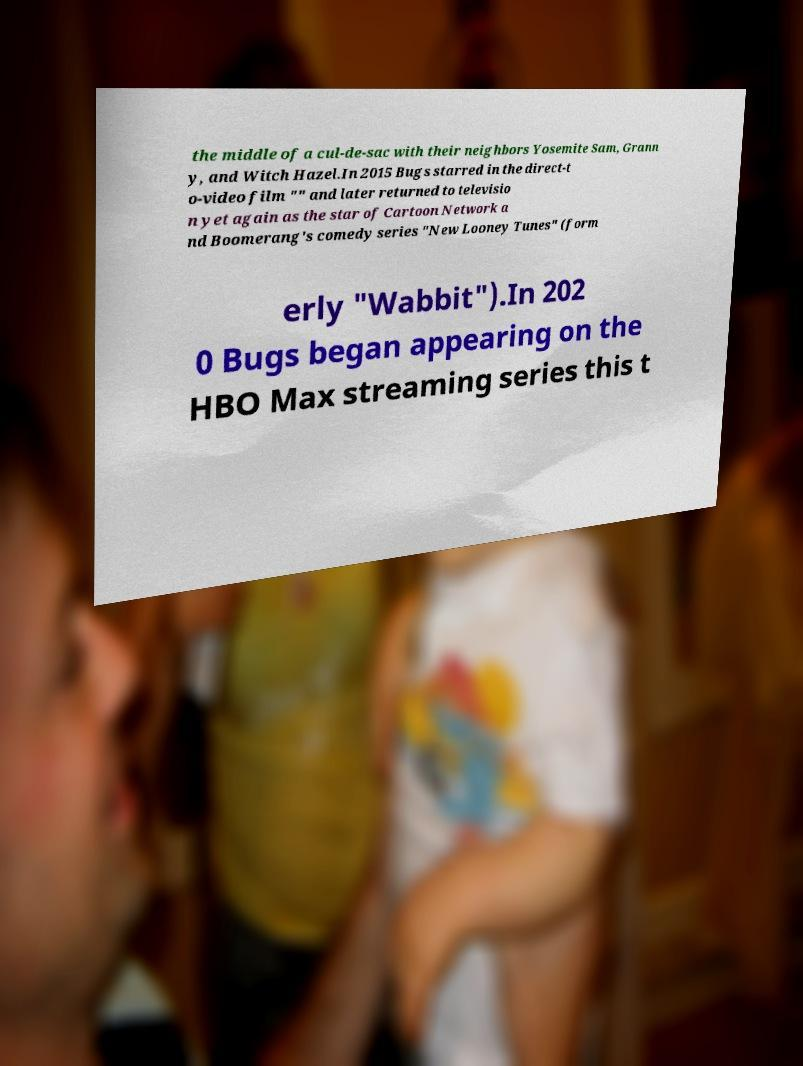For documentation purposes, I need the text within this image transcribed. Could you provide that? the middle of a cul-de-sac with their neighbors Yosemite Sam, Grann y, and Witch Hazel.In 2015 Bugs starred in the direct-t o-video film "" and later returned to televisio n yet again as the star of Cartoon Network a nd Boomerang's comedy series "New Looney Tunes" (form erly "Wabbit").In 202 0 Bugs began appearing on the HBO Max streaming series this t 